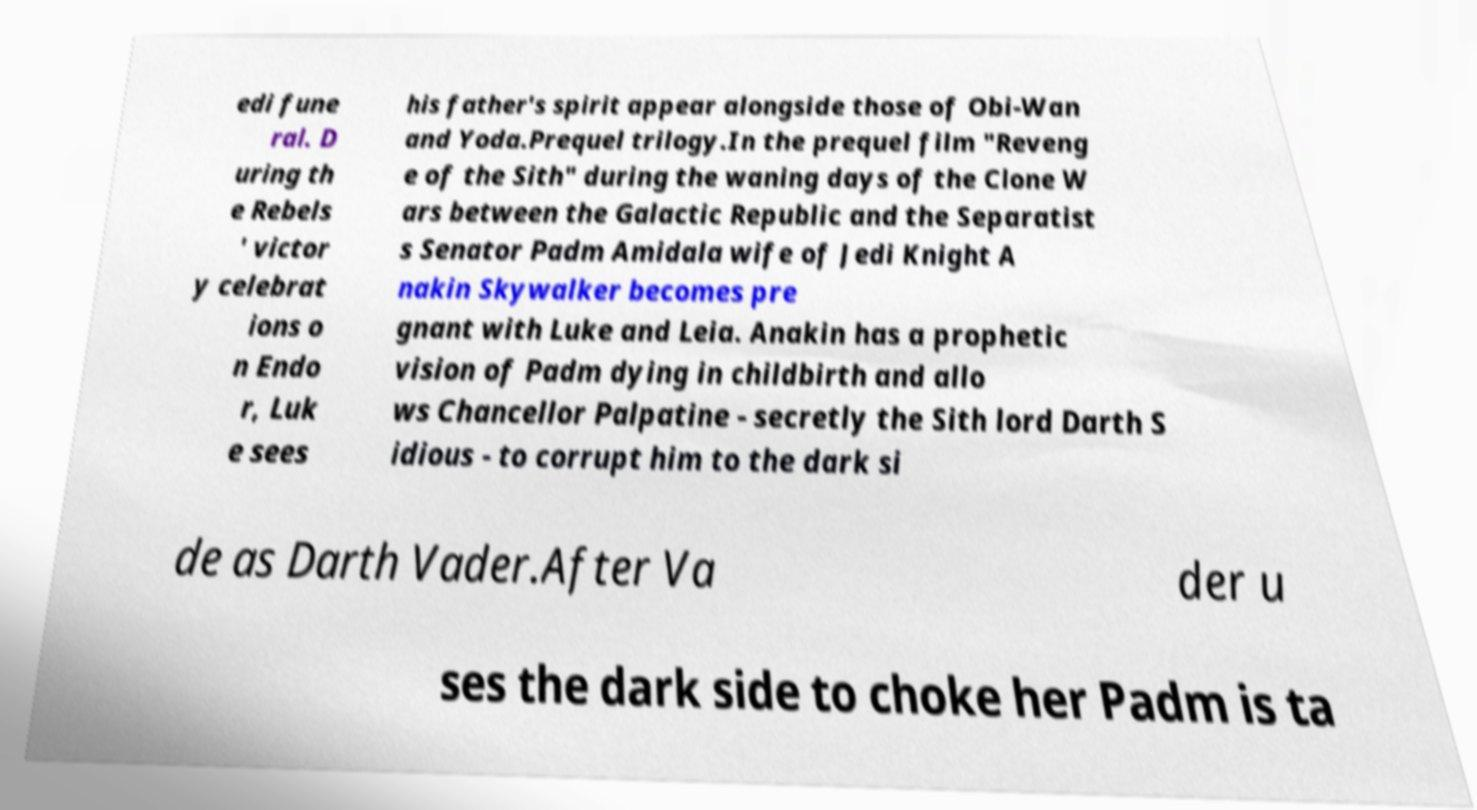Can you read and provide the text displayed in the image?This photo seems to have some interesting text. Can you extract and type it out for me? edi fune ral. D uring th e Rebels ' victor y celebrat ions o n Endo r, Luk e sees his father's spirit appear alongside those of Obi-Wan and Yoda.Prequel trilogy.In the prequel film "Reveng e of the Sith" during the waning days of the Clone W ars between the Galactic Republic and the Separatist s Senator Padm Amidala wife of Jedi Knight A nakin Skywalker becomes pre gnant with Luke and Leia. Anakin has a prophetic vision of Padm dying in childbirth and allo ws Chancellor Palpatine - secretly the Sith lord Darth S idious - to corrupt him to the dark si de as Darth Vader.After Va der u ses the dark side to choke her Padm is ta 